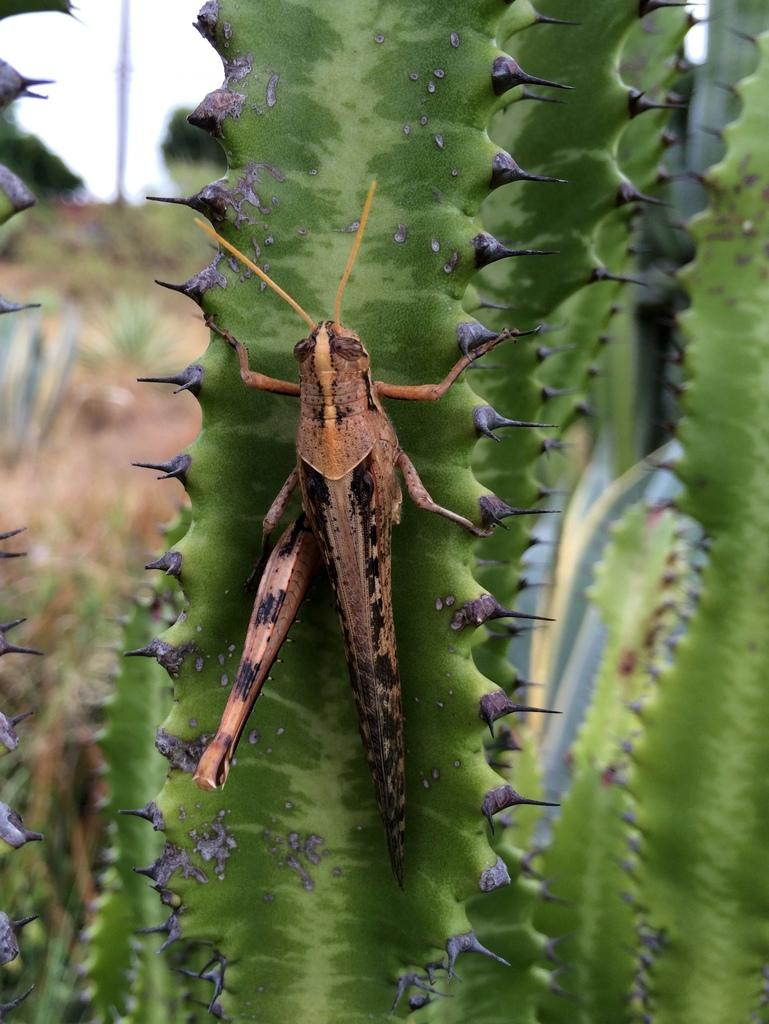What type of living organisms can be seen in the image? Plants and an insect are visible in the image. What can be seen in the background of the image? The sky is visible in the image. Based on the presence of the sky and the absence of any artificial lighting, when do you think the image was likely taken? The image was likely taken during the day. What type of ornament is hanging from the plant in the image? There is no ornament hanging from the plant in the image; it only features plants and an insect. How many fingers can be seen in the image? There are no fingers visible in the image. 